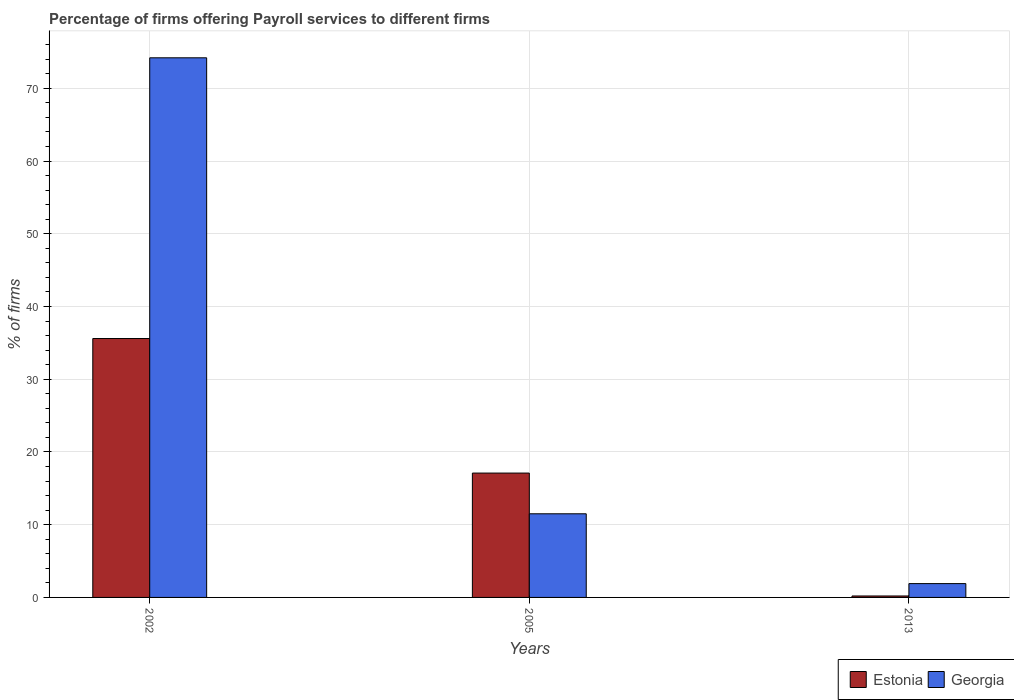How many different coloured bars are there?
Your answer should be very brief. 2. How many groups of bars are there?
Offer a very short reply. 3. Are the number of bars per tick equal to the number of legend labels?
Offer a terse response. Yes. Are the number of bars on each tick of the X-axis equal?
Keep it short and to the point. Yes. In how many cases, is the number of bars for a given year not equal to the number of legend labels?
Ensure brevity in your answer.  0. What is the percentage of firms offering payroll services in Georgia in 2013?
Provide a succinct answer. 1.9. Across all years, what is the maximum percentage of firms offering payroll services in Georgia?
Your answer should be compact. 74.2. Across all years, what is the minimum percentage of firms offering payroll services in Georgia?
Provide a short and direct response. 1.9. What is the total percentage of firms offering payroll services in Estonia in the graph?
Your answer should be compact. 52.9. What is the difference between the percentage of firms offering payroll services in Estonia in 2002 and that in 2013?
Keep it short and to the point. 35.4. What is the difference between the percentage of firms offering payroll services in Estonia in 2005 and the percentage of firms offering payroll services in Georgia in 2002?
Make the answer very short. -57.1. What is the average percentage of firms offering payroll services in Georgia per year?
Provide a succinct answer. 29.2. In the year 2013, what is the difference between the percentage of firms offering payroll services in Georgia and percentage of firms offering payroll services in Estonia?
Provide a succinct answer. 1.7. In how many years, is the percentage of firms offering payroll services in Estonia greater than 2 %?
Ensure brevity in your answer.  2. What is the ratio of the percentage of firms offering payroll services in Estonia in 2005 to that in 2013?
Ensure brevity in your answer.  85.5. Is the percentage of firms offering payroll services in Georgia in 2002 less than that in 2005?
Give a very brief answer. No. Is the difference between the percentage of firms offering payroll services in Georgia in 2005 and 2013 greater than the difference between the percentage of firms offering payroll services in Estonia in 2005 and 2013?
Give a very brief answer. No. What is the difference between the highest and the second highest percentage of firms offering payroll services in Estonia?
Your answer should be very brief. 18.5. What is the difference between the highest and the lowest percentage of firms offering payroll services in Estonia?
Offer a very short reply. 35.4. In how many years, is the percentage of firms offering payroll services in Georgia greater than the average percentage of firms offering payroll services in Georgia taken over all years?
Your answer should be very brief. 1. What does the 1st bar from the left in 2013 represents?
Give a very brief answer. Estonia. What does the 1st bar from the right in 2013 represents?
Your response must be concise. Georgia. Are all the bars in the graph horizontal?
Keep it short and to the point. No. How many years are there in the graph?
Your answer should be compact. 3. What is the difference between two consecutive major ticks on the Y-axis?
Your answer should be compact. 10. Does the graph contain any zero values?
Provide a succinct answer. No. Does the graph contain grids?
Offer a terse response. Yes. Where does the legend appear in the graph?
Give a very brief answer. Bottom right. How many legend labels are there?
Provide a short and direct response. 2. How are the legend labels stacked?
Keep it short and to the point. Horizontal. What is the title of the graph?
Give a very brief answer. Percentage of firms offering Payroll services to different firms. Does "Grenada" appear as one of the legend labels in the graph?
Your answer should be very brief. No. What is the label or title of the Y-axis?
Your answer should be very brief. % of firms. What is the % of firms in Estonia in 2002?
Provide a succinct answer. 35.6. What is the % of firms in Georgia in 2002?
Offer a terse response. 74.2. What is the % of firms in Estonia in 2013?
Ensure brevity in your answer.  0.2. What is the % of firms of Georgia in 2013?
Offer a very short reply. 1.9. Across all years, what is the maximum % of firms of Estonia?
Give a very brief answer. 35.6. Across all years, what is the maximum % of firms of Georgia?
Offer a very short reply. 74.2. Across all years, what is the minimum % of firms in Estonia?
Provide a succinct answer. 0.2. What is the total % of firms of Estonia in the graph?
Your response must be concise. 52.9. What is the total % of firms in Georgia in the graph?
Provide a short and direct response. 87.6. What is the difference between the % of firms in Estonia in 2002 and that in 2005?
Your response must be concise. 18.5. What is the difference between the % of firms of Georgia in 2002 and that in 2005?
Provide a succinct answer. 62.7. What is the difference between the % of firms in Estonia in 2002 and that in 2013?
Provide a succinct answer. 35.4. What is the difference between the % of firms in Georgia in 2002 and that in 2013?
Offer a very short reply. 72.3. What is the difference between the % of firms in Estonia in 2005 and that in 2013?
Your response must be concise. 16.9. What is the difference between the % of firms in Georgia in 2005 and that in 2013?
Ensure brevity in your answer.  9.6. What is the difference between the % of firms of Estonia in 2002 and the % of firms of Georgia in 2005?
Provide a short and direct response. 24.1. What is the difference between the % of firms of Estonia in 2002 and the % of firms of Georgia in 2013?
Your answer should be compact. 33.7. What is the average % of firms in Estonia per year?
Offer a very short reply. 17.63. What is the average % of firms of Georgia per year?
Offer a terse response. 29.2. In the year 2002, what is the difference between the % of firms of Estonia and % of firms of Georgia?
Your answer should be very brief. -38.6. What is the ratio of the % of firms of Estonia in 2002 to that in 2005?
Your answer should be compact. 2.08. What is the ratio of the % of firms in Georgia in 2002 to that in 2005?
Make the answer very short. 6.45. What is the ratio of the % of firms in Estonia in 2002 to that in 2013?
Make the answer very short. 178. What is the ratio of the % of firms of Georgia in 2002 to that in 2013?
Your response must be concise. 39.05. What is the ratio of the % of firms in Estonia in 2005 to that in 2013?
Provide a short and direct response. 85.5. What is the ratio of the % of firms of Georgia in 2005 to that in 2013?
Provide a short and direct response. 6.05. What is the difference between the highest and the second highest % of firms of Georgia?
Ensure brevity in your answer.  62.7. What is the difference between the highest and the lowest % of firms in Estonia?
Give a very brief answer. 35.4. What is the difference between the highest and the lowest % of firms in Georgia?
Your answer should be very brief. 72.3. 